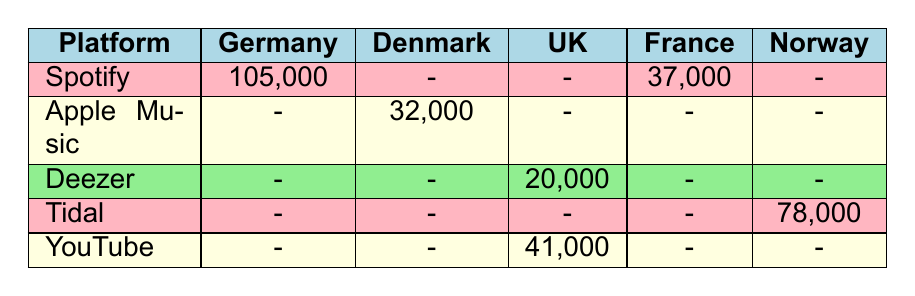What is the total number of streams for songs on Spotify in Germany? The table shows the streams for songs on Spotify in Germany: "Dye My Hair" by Alma (45,000) and "No Roots" by Alice Merton (60,000). Therefore, adding these values gives 45,000 + 60,000 = 105,000.
Answer: 105,000 Which platform has the highest number of streams for songs in Norway? The table lists streams for Tidal (78,000) and AURORA's "Runaway" (50,000). Tidal has the highest streams among the platforms mentioned.
Answer: Tidal Is there any data for songs streamed on Apple Music in the UK? The table indicates that there are no streams listed for Apple Music in the UK, as that cell is marked with a dash (-).
Answer: No What is the combined total number of streams for songs in the UK? The table records two songs for the UK: "Heartsong" by Hannah Grace (20,000) and "Bad Taste" by LolaYoung (41,000). Adding these gives 20,000 + 41,000 = 61,000.
Answer: 61,000 Does Deezer have any streaming data for songs in France? The table lacks any entries for Deezer in France, which is indicated by the dash (-). Therefore, there is no streaming data for Deezer in France.
Answer: No What is the average number of streams listed across all platforms in Germany? The total streams for Germany are from Spotify: 105,000. As there’s only one platform with data, the average is 105,000/1 = 105,000.
Answer: 105,000 Which song has the lowest number of streams in the table? The data shows "Right Now" by Sophie and the Giants with 15,000 streams is the lowest, as it is the only entry below 20,000 when comparing all entries.
Answer: Right Now What is the difference in streaming numbers between the highest and lowest streams on YouTube? The only entry on YouTube is "Bad Taste" by LolaYoung with 41,000 streams. As there is no lowest entry to compare, we can conclude that the difference between highest and lowest is 0.
Answer: 0 How many streams does the song "Runaway" have compared to the total on Tidal? "Runaway" by AURORA has 50,000 streams compared to Tidal's total of 78,000 streams. The difference is 78,000 - 50,000 = 28,000.
Answer: 28,000 What percentage of the total streams on Spotify is attributed to "No Roots" by Alice Merton? The total for Spotify is 105,000, and "No Roots" has 60,000. To find the percentage: (60,000 / 105,000) × 100 = 57.14%.
Answer: 57.14% 